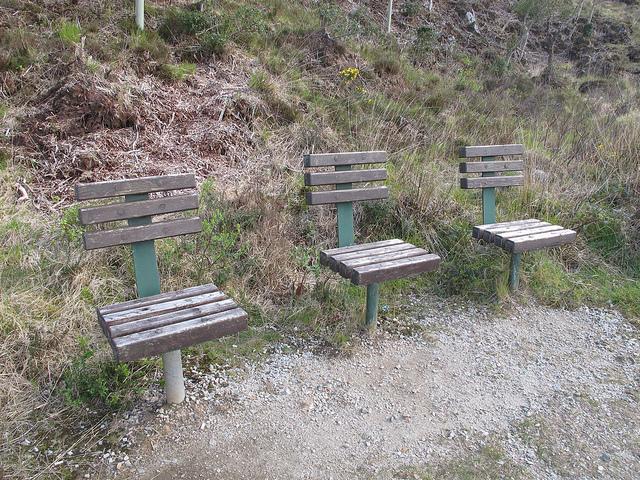How many seats are there in the picture?
Give a very brief answer. 3. How many legs are on the bench?
Give a very brief answer. 1. How many places to sit are available?
Give a very brief answer. 3. How many benches are in the photo?
Give a very brief answer. 3. 